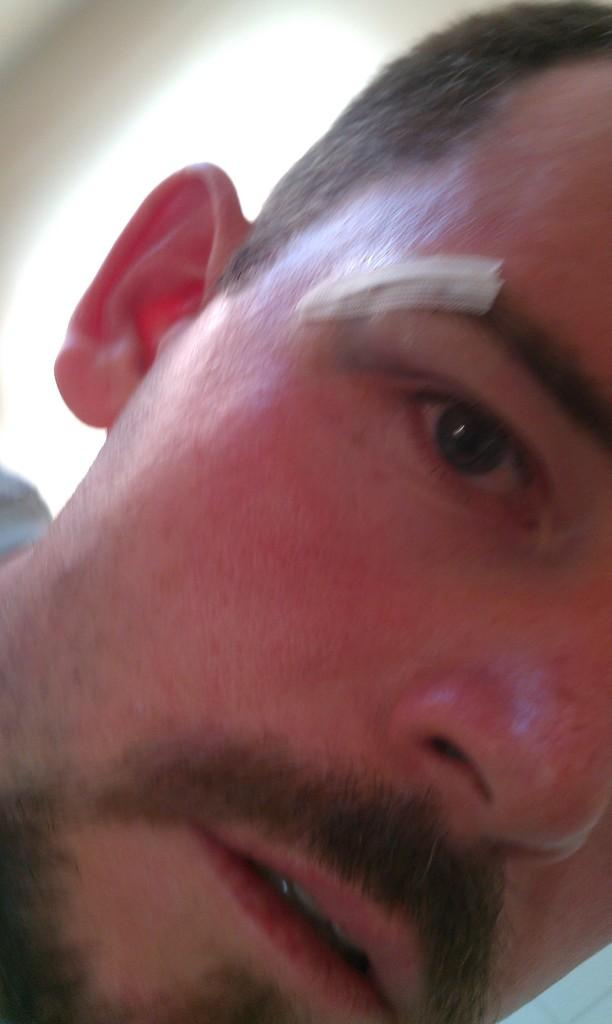What is there is a person in the image, can you describe them? There is a person in the image, but their appearance cannot be determined from the provided facts. What can be seen in the background of the image? There is a wall in the background of the image. What type of shoe is the person wearing in the image? There is no information about the person's shoes in the image, so it cannot be determined. How much does the scale in the image weigh? There is no scale present in the image, so it cannot be weighed. 